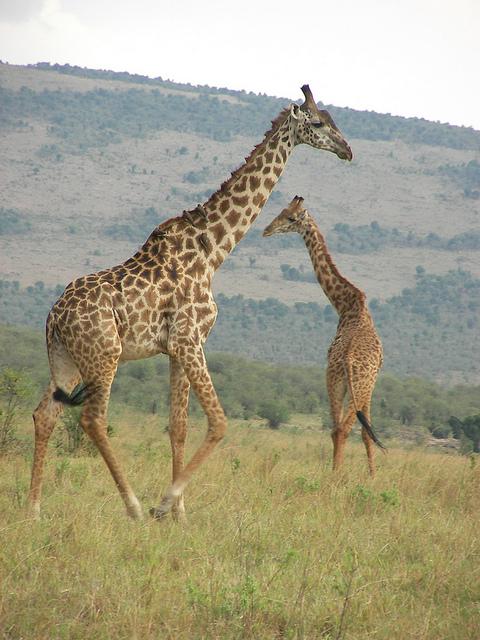Who feeds the animals?
Short answer required. Nature. Is the giraffe standing on grass?
Give a very brief answer. Yes. How many giraffes are standing?
Keep it brief. 2. Are the giraffes in the wild or are they in a zoo?
Be succinct. Wild. Are the giraffes hungry?
Be succinct. No. Is this the zoo?
Short answer required. No. How many baby giraffes are in the field?
Answer briefly. 1. Will these giraffes mate?
Write a very short answer. No. How many giraffes are there?
Concise answer only. 2. Where are the giraffes?
Quick response, please. In field. 